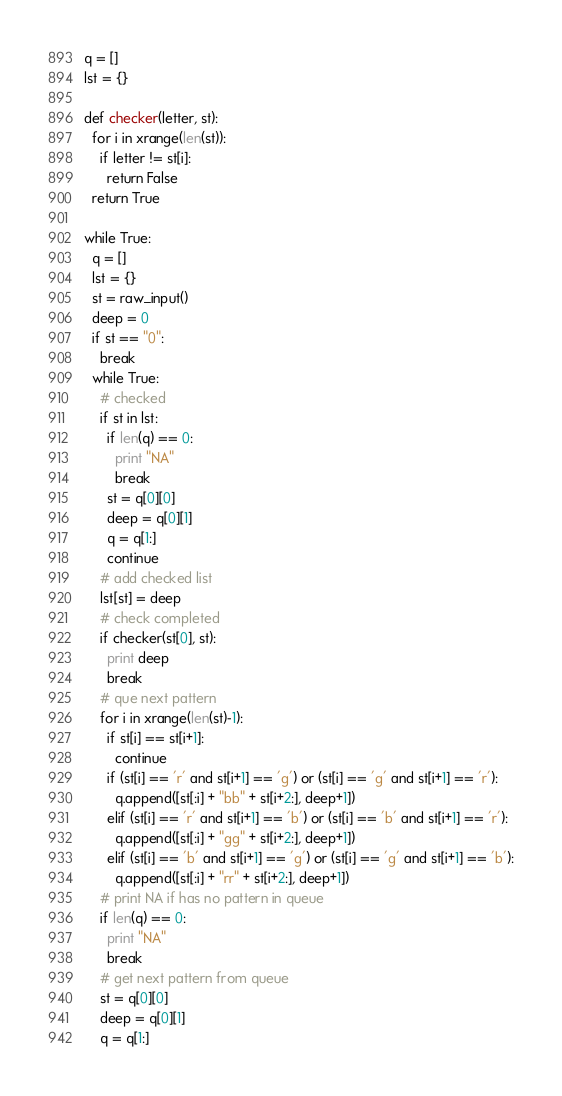Convert code to text. <code><loc_0><loc_0><loc_500><loc_500><_Python_>q = []
lst = {}

def checker(letter, st):
  for i in xrange(len(st)):
    if letter != st[i]:
      return False
  return True

while True:
  q = []
  lst = {}
  st = raw_input()
  deep = 0
  if st == "0":
    break
  while True:
    # checked
    if st in lst:
      if len(q) == 0:
        print "NA"
        break
      st = q[0][0]
      deep = q[0][1]
      q = q[1:]
      continue
    # add checked list
    lst[st] = deep
    # check completed
    if checker(st[0], st):
      print deep
      break
    # que next pattern
    for i in xrange(len(st)-1):
      if st[i] == st[i+1]:
        continue
      if (st[i] == 'r' and st[i+1] == 'g') or (st[i] == 'g' and st[i+1] == 'r'):
        q.append([st[:i] + "bb" + st[i+2:], deep+1])
      elif (st[i] == 'r' and st[i+1] == 'b') or (st[i] == 'b' and st[i+1] == 'r'):
        q.append([st[:i] + "gg" + st[i+2:], deep+1])
      elif (st[i] == 'b' and st[i+1] == 'g') or (st[i] == 'g' and st[i+1] == 'b'):
        q.append([st[:i] + "rr" + st[i+2:], deep+1])
    # print NA if has no pattern in queue
    if len(q) == 0:
      print "NA"
      break
    # get next pattern from queue
    st = q[0][0]
    deep = q[0][1]
    q = q[1:]</code> 